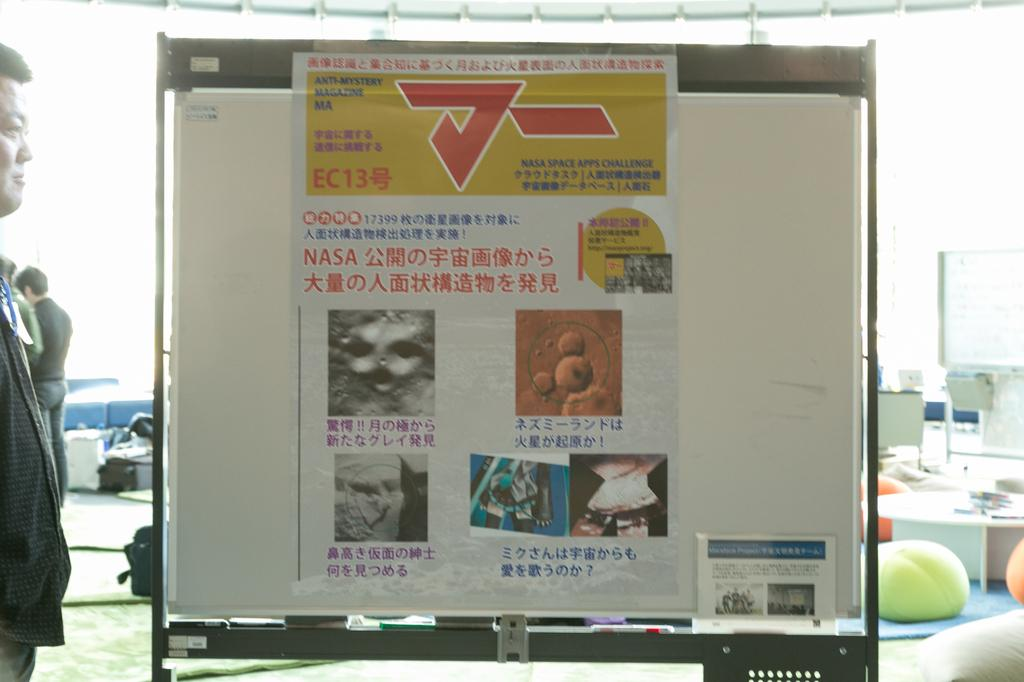<image>
Present a compact description of the photo's key features. White poster with the word NASA near the middle. 